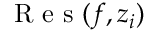<formula> <loc_0><loc_0><loc_500><loc_500>R e s ( f , z _ { i } )</formula> 